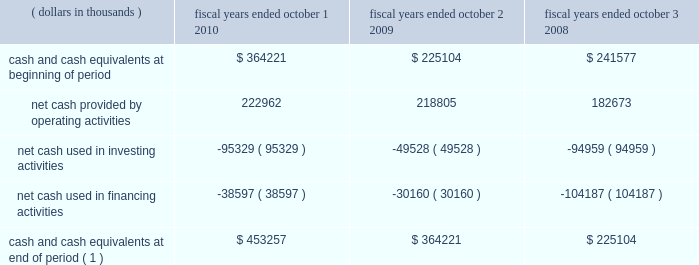31mar201122064257 positions which were required to be capitalized .
There are no positions which we anticipate could change materially within the next twelve months .
Liquidity and capital resources .
( 1 ) does not include restricted cash balances cash flow from operating activities : cash provided from operating activities is net income adjusted for certain non-cash items and changes in certain assets and liabilities .
For fiscal year 2010 we generated $ 223.0 million in cash flow from operations , an increase of $ 4.2 million when compared to the $ 218.8 million generated in fiscal year 2009 .
During fiscal year 2010 , net income increased by $ 42.3 million to $ 137.3 million when compared to fiscal year 2009 .
Despite the increase in net income , net cash provided by operating activities remained relatively consistent .
This was primarily due to : 2022 fiscal year 2010 net income included a deferred tax expense of $ 38.5 million compared to a $ 24.9 million deferred tax benefit included in 2009 net income due to the release of the tax valuation allowance in fiscal year 2009 .
2022 during fiscal year 2010 , the company invested in working capital as result of higher business activity .
Compared to fiscal year 2009 , accounts receivable , inventory and accounts payable increased by $ 60.9 million , $ 38.8 million and $ 42.9 million , respectively .
Cash flow from investing activities : cash flow from investing activities consists primarily of capital expenditures and acquisitions .
We had net cash outflows of $ 95.3 million in fiscal year 2010 , compared to $ 49.5 million in fiscal year 2009 .
The increase is primarily due to an increase of $ 49.8 million in capital expenditures .
We anticipate our capital spending to be consistent in fiscal year 2011 to maintain our projected growth rate .
Cash flow from financing activities : cash flows from financing activities consist primarily of cash transactions related to debt and equity .
During fiscal year 2010 , we had net cash outflows of $ 38.6 million , compared to $ 30.2 million in fiscal year 2009 .
During the year we had the following significant transactions : 2022 we retired $ 53.0 million in aggregate principal amount ( carrying value of $ 51.1 million ) of 2007 convertible notes for $ 80.7 million , which included a $ 29.6 million premium paid for the equity component of the instrument .
2022 we received net proceeds from employee stock option exercises of $ 40.5 million in fiscal year 2010 , compared to $ 38.7 million in fiscal year 2009 .
Skyworks / 2010 annual report 103 .
What was the percentage change in the net cash outflows in 2010 compared to 2009? 
Computations: ((95.3 - 49.5) / 49.5)
Answer: 0.92525. 